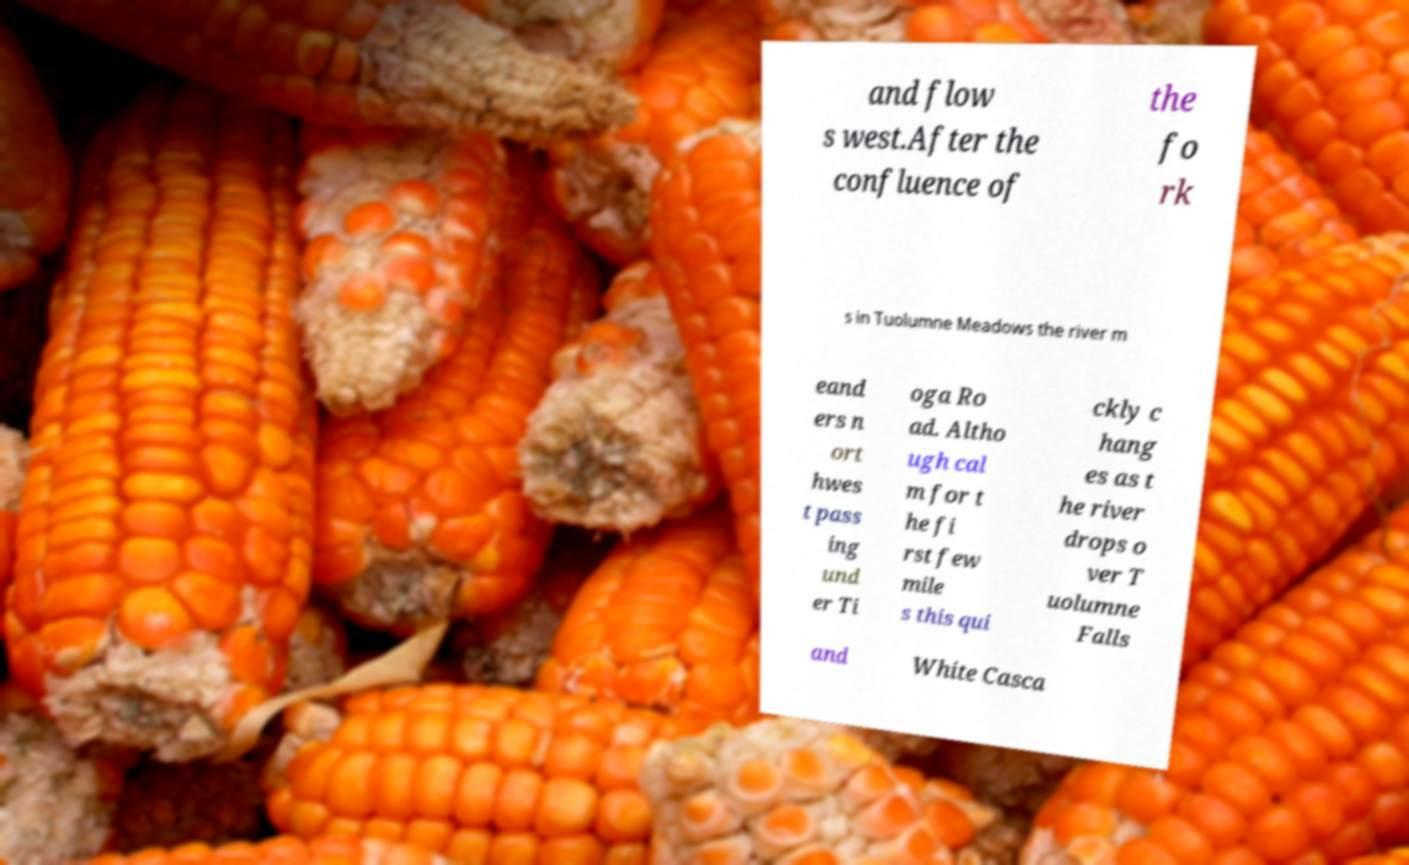Please read and relay the text visible in this image. What does it say? and flow s west.After the confluence of the fo rk s in Tuolumne Meadows the river m eand ers n ort hwes t pass ing und er Ti oga Ro ad. Altho ugh cal m for t he fi rst few mile s this qui ckly c hang es as t he river drops o ver T uolumne Falls and White Casca 